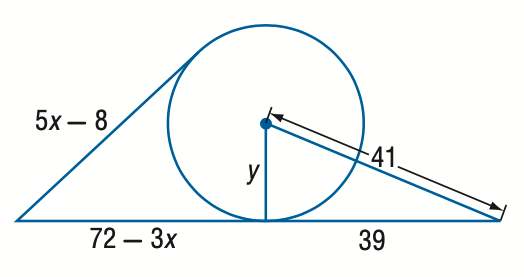Question: Find y. Assume that segments that appear to be tangent are tangent. Round to the nearest tenth if necessary.
Choices:
A. 10.6
B. 11.6
C. 12.6
D. 13.6
Answer with the letter. Answer: C 